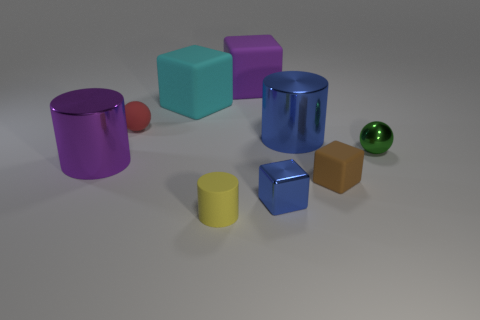Add 1 tiny blue objects. How many objects exist? 10 Subtract all yellow cylinders. How many cylinders are left? 2 Subtract all yellow rubber cylinders. How many cylinders are left? 2 Subtract all cylinders. How many objects are left? 6 Subtract 2 cubes. How many cubes are left? 2 Subtract all gray cubes. How many red spheres are left? 1 Add 3 cyan cubes. How many cyan cubes are left? 4 Add 8 yellow matte blocks. How many yellow matte blocks exist? 8 Subtract 1 green balls. How many objects are left? 8 Subtract all cyan blocks. Subtract all purple cylinders. How many blocks are left? 3 